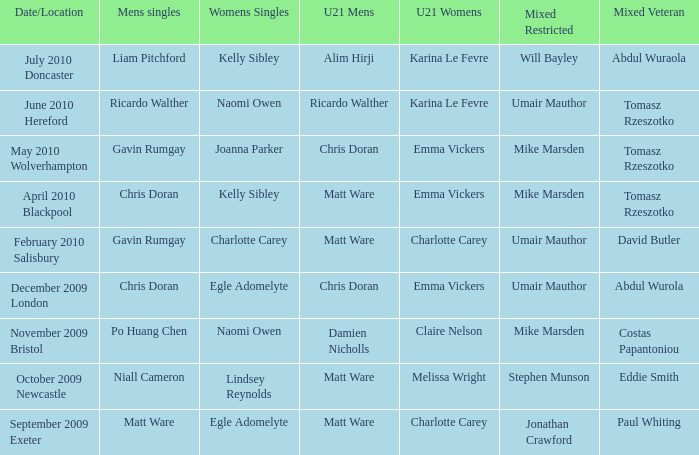Who was the U21 Mens winner when Mike Marsden was the mixed restricted winner and Claire Nelson was the U21 Womens winner?  Damien Nicholls. 